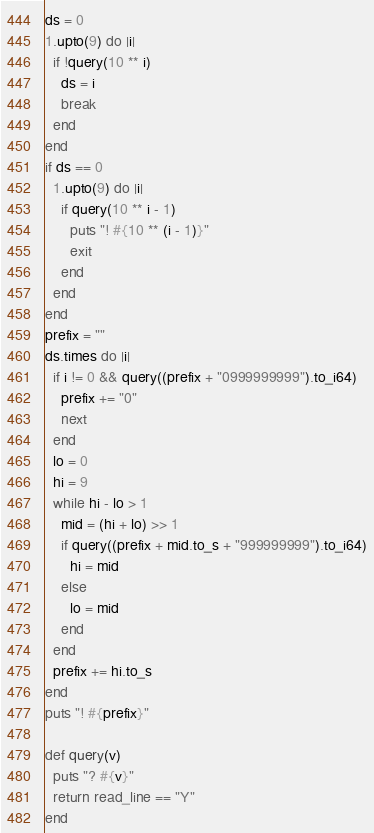Convert code to text. <code><loc_0><loc_0><loc_500><loc_500><_Crystal_>ds = 0
1.upto(9) do |i|
  if !query(10 ** i)
    ds = i
    break
  end
end
if ds == 0
  1.upto(9) do |i|
    if query(10 ** i - 1)
      puts "! #{10 ** (i - 1)}"
      exit
    end
  end
end
prefix = ""
ds.times do |i|
  if i != 0 && query((prefix + "0999999999").to_i64)
    prefix += "0"
    next
  end
  lo = 0
  hi = 9
  while hi - lo > 1
    mid = (hi + lo) >> 1
    if query((prefix + mid.to_s + "999999999").to_i64)
      hi = mid
    else
      lo = mid
    end
  end
  prefix += hi.to_s
end
puts "! #{prefix}"

def query(v)
  puts "? #{v}"
  return read_line == "Y"
end
</code> 